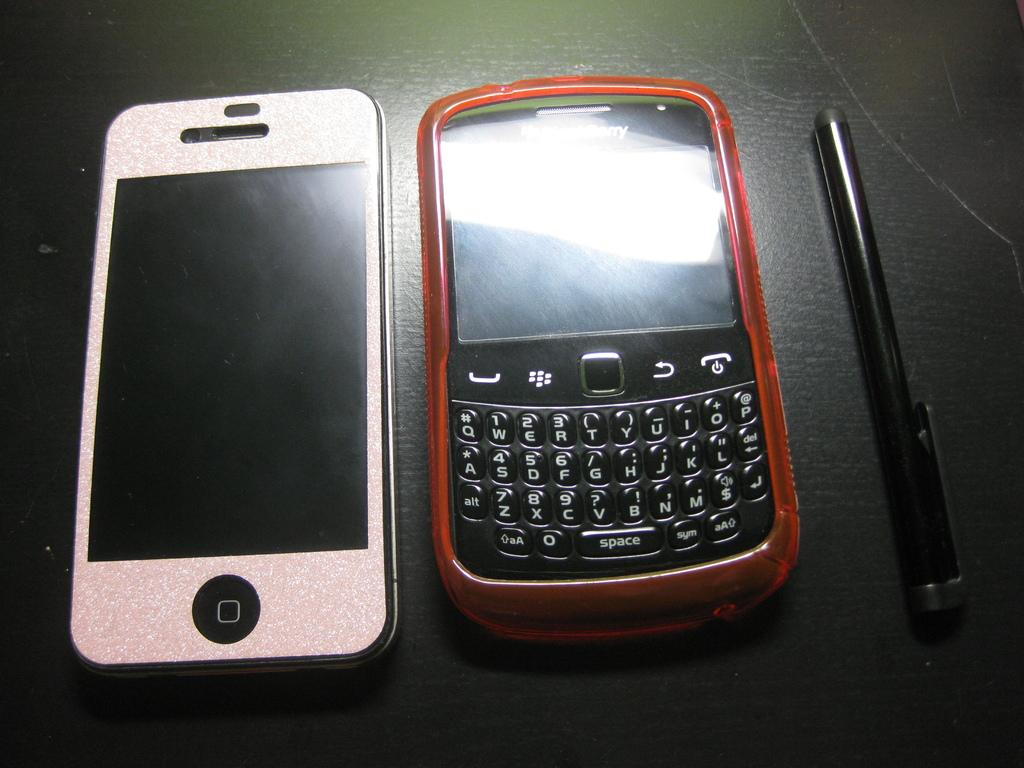<image>
Present a compact description of the photo's key features. Two silver and orange cell phones with keys for SPACE on a table 